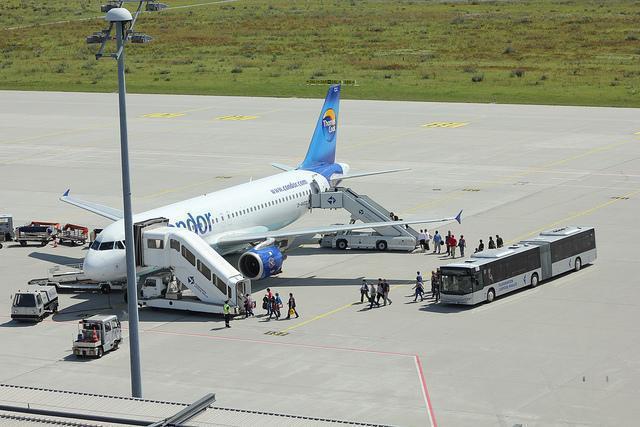What is the name of the blue piece on the end of the plane?
From the following set of four choices, select the accurate answer to respond to the question.
Options: Slats, wing, spoiler, vertical stabilizer. Vertical stabilizer. 